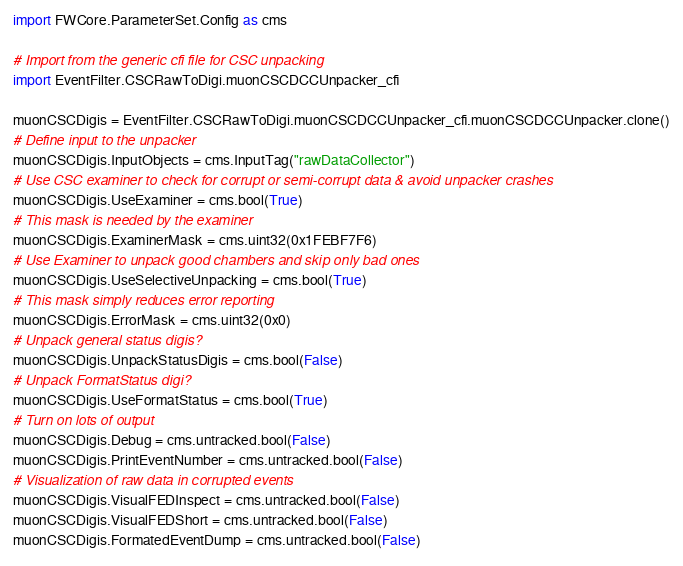<code> <loc_0><loc_0><loc_500><loc_500><_Python_>import FWCore.ParameterSet.Config as cms

# Import from the generic cfi file for CSC unpacking
import EventFilter.CSCRawToDigi.muonCSCDCCUnpacker_cfi

muonCSCDigis = EventFilter.CSCRawToDigi.muonCSCDCCUnpacker_cfi.muonCSCDCCUnpacker.clone()
# Define input to the unpacker
muonCSCDigis.InputObjects = cms.InputTag("rawDataCollector")
# Use CSC examiner to check for corrupt or semi-corrupt data & avoid unpacker crashes
muonCSCDigis.UseExaminer = cms.bool(True)
# This mask is needed by the examiner 
muonCSCDigis.ExaminerMask = cms.uint32(0x1FEBF7F6)
# Use Examiner to unpack good chambers and skip only bad ones
muonCSCDigis.UseSelectiveUnpacking = cms.bool(True)
# This mask simply reduces error reporting
muonCSCDigis.ErrorMask = cms.uint32(0x0)
# Unpack general status digis?
muonCSCDigis.UnpackStatusDigis = cms.bool(False)
# Unpack FormatStatus digi?
muonCSCDigis.UseFormatStatus = cms.bool(True)
# Turn on lots of output
muonCSCDigis.Debug = cms.untracked.bool(False)
muonCSCDigis.PrintEventNumber = cms.untracked.bool(False)
# Visualization of raw data in corrupted events
muonCSCDigis.VisualFEDInspect = cms.untracked.bool(False)
muonCSCDigis.VisualFEDShort = cms.untracked.bool(False)
muonCSCDigis.FormatedEventDump = cms.untracked.bool(False)
</code> 